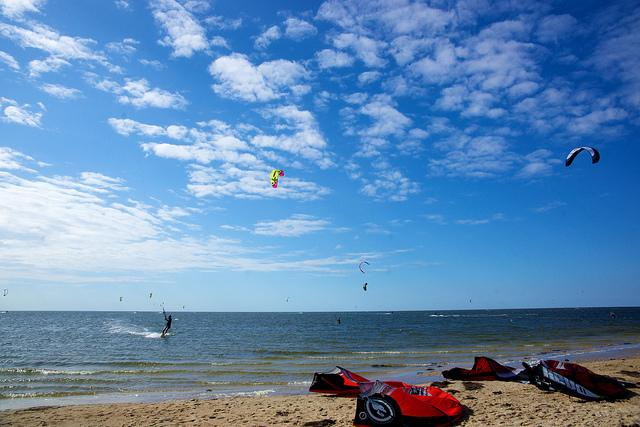What is in the sky?

Choices:
A) egg
B) kite
C) frisbee
D) rocket kite 